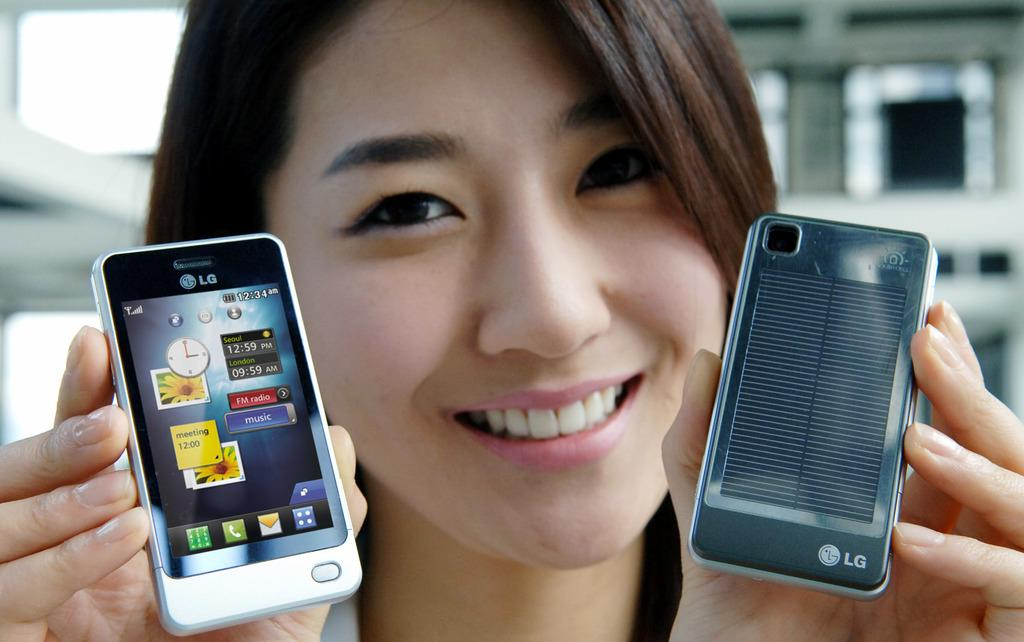<image>
Give a short and clear explanation of the subsequent image. A lady holding up two cell phones which are both made by LG. 